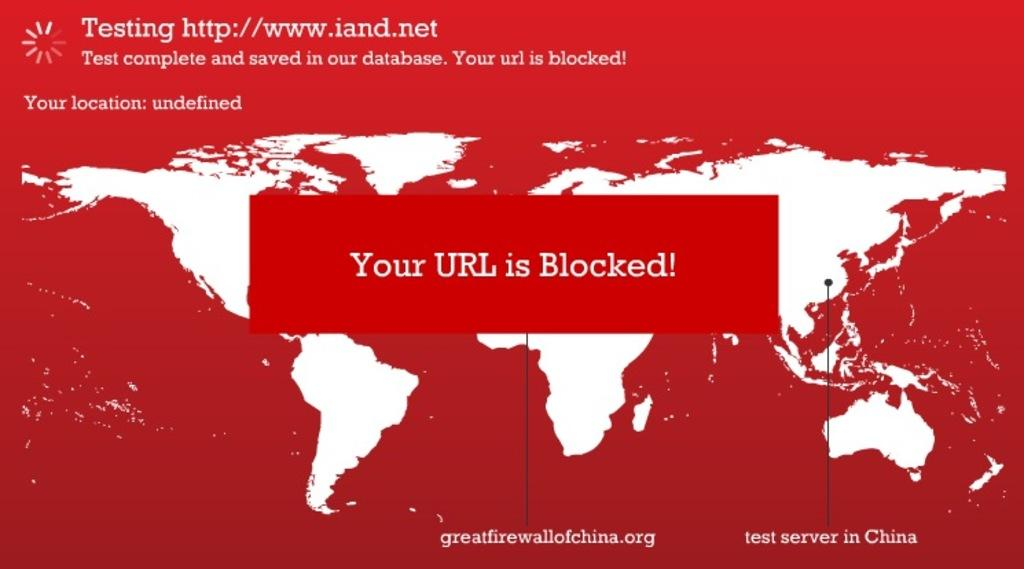<image>
Present a compact description of the photo's key features. Card that says that the URL is blocked. 